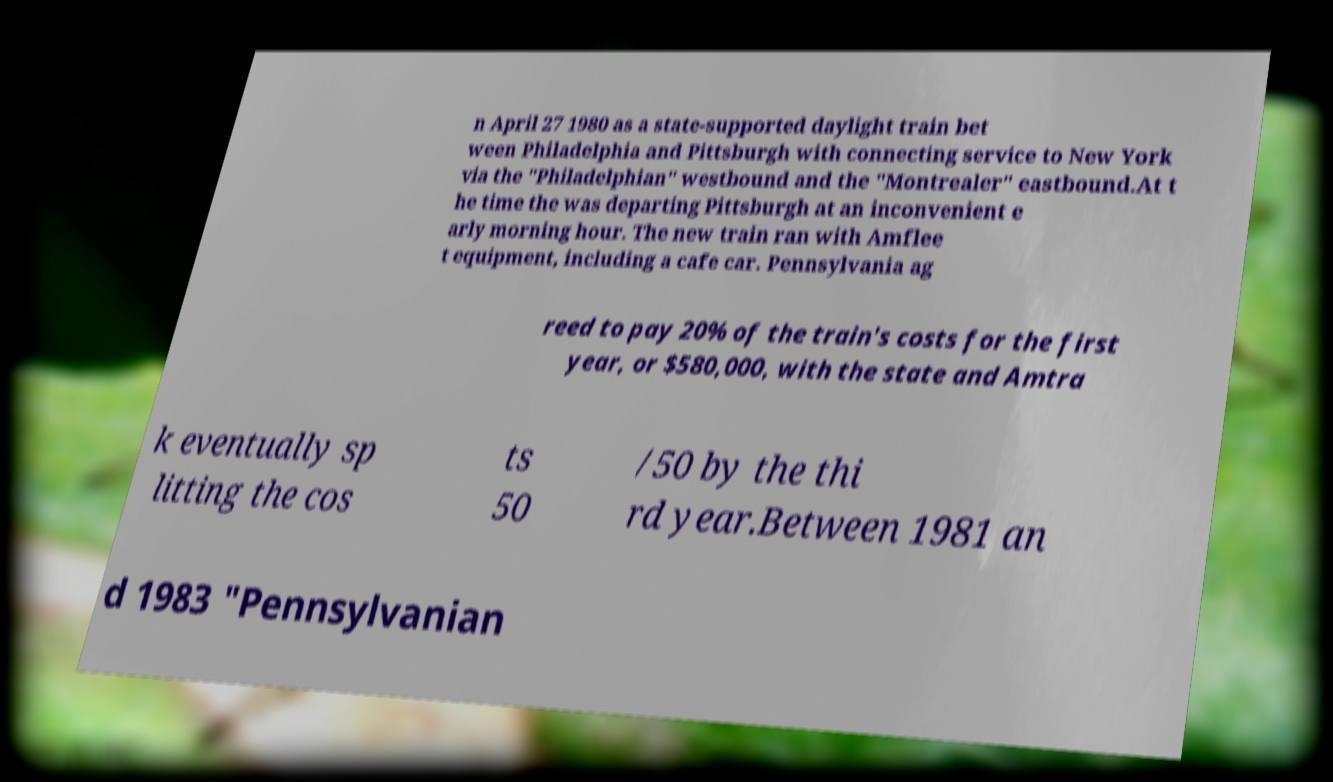Please read and relay the text visible in this image. What does it say? n April 27 1980 as a state-supported daylight train bet ween Philadelphia and Pittsburgh with connecting service to New York via the "Philadelphian" westbound and the "Montrealer" eastbound.At t he time the was departing Pittsburgh at an inconvenient e arly morning hour. The new train ran with Amflee t equipment, including a cafe car. Pennsylvania ag reed to pay 20% of the train's costs for the first year, or $580,000, with the state and Amtra k eventually sp litting the cos ts 50 /50 by the thi rd year.Between 1981 an d 1983 "Pennsylvanian 